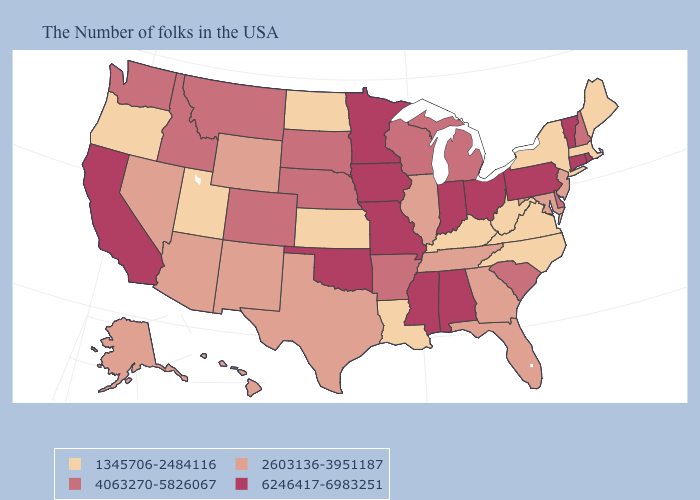Is the legend a continuous bar?
Quick response, please. No. Does Nebraska have a lower value than Alabama?
Answer briefly. Yes. Does the first symbol in the legend represent the smallest category?
Keep it brief. Yes. Among the states that border New York , does Massachusetts have the highest value?
Concise answer only. No. Among the states that border Massachusetts , which have the lowest value?
Concise answer only. New York. Which states have the lowest value in the MidWest?
Answer briefly. Kansas, North Dakota. What is the value of West Virginia?
Answer briefly. 1345706-2484116. What is the lowest value in the MidWest?
Quick response, please. 1345706-2484116. Does California have the lowest value in the USA?
Be succinct. No. Which states hav the highest value in the West?
Short answer required. California. What is the value of Connecticut?
Short answer required. 6246417-6983251. What is the highest value in the USA?
Quick response, please. 6246417-6983251. Among the states that border Rhode Island , which have the highest value?
Answer briefly. Connecticut. Name the states that have a value in the range 6246417-6983251?
Quick response, please. Rhode Island, Vermont, Connecticut, Pennsylvania, Ohio, Indiana, Alabama, Mississippi, Missouri, Minnesota, Iowa, Oklahoma, California. Does the map have missing data?
Short answer required. No. 